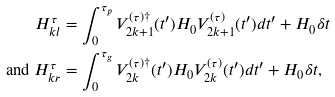Convert formula to latex. <formula><loc_0><loc_0><loc_500><loc_500>H _ { k l } ^ { \tau } & = \int _ { 0 } ^ { \tau _ { p } } V _ { 2 k + 1 } ^ { ( \tau ) \dagger } ( t ^ { \prime } ) H _ { 0 } V _ { 2 k + 1 } ^ { ( \tau ) } ( t ^ { \prime } ) d t ^ { \prime } + H _ { 0 } \delta t \\ \text { and } H _ { k r } ^ { \tau } & = \int _ { 0 } ^ { \tau _ { g } } V _ { 2 k } ^ { ( \tau ) \dagger } ( t ^ { \prime } ) H _ { 0 } V _ { 2 k } ^ { ( \tau ) } ( t ^ { \prime } ) d t ^ { \prime } + H _ { 0 } \delta t ,</formula> 